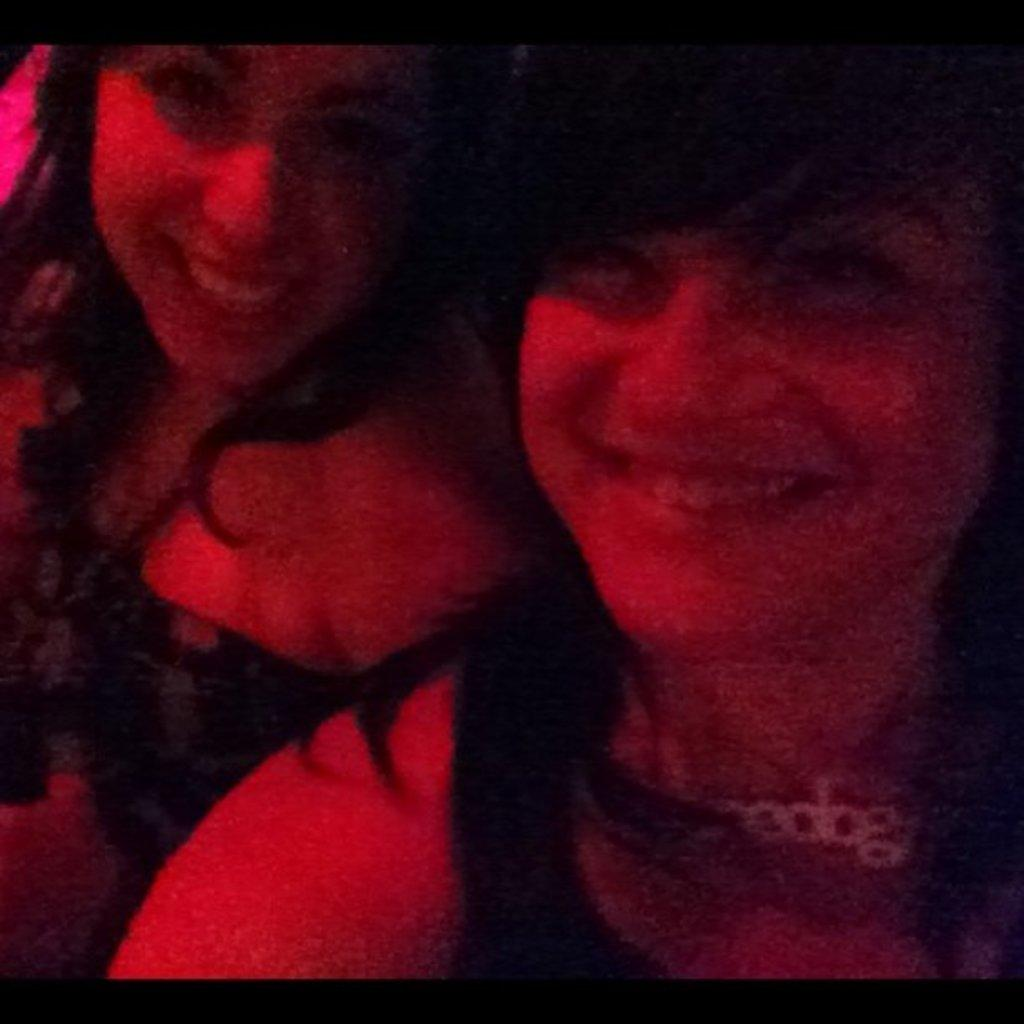How many people are in the image? There are two women in the image. What expressions do the women have? Both women are smiling. What can be observed about the lighting in the image? There is red color light on the faces of the women. Where is the kite being flown in the image? There is no kite present in the image. How many bears are visible in the image? There are no bears visible in the image. 